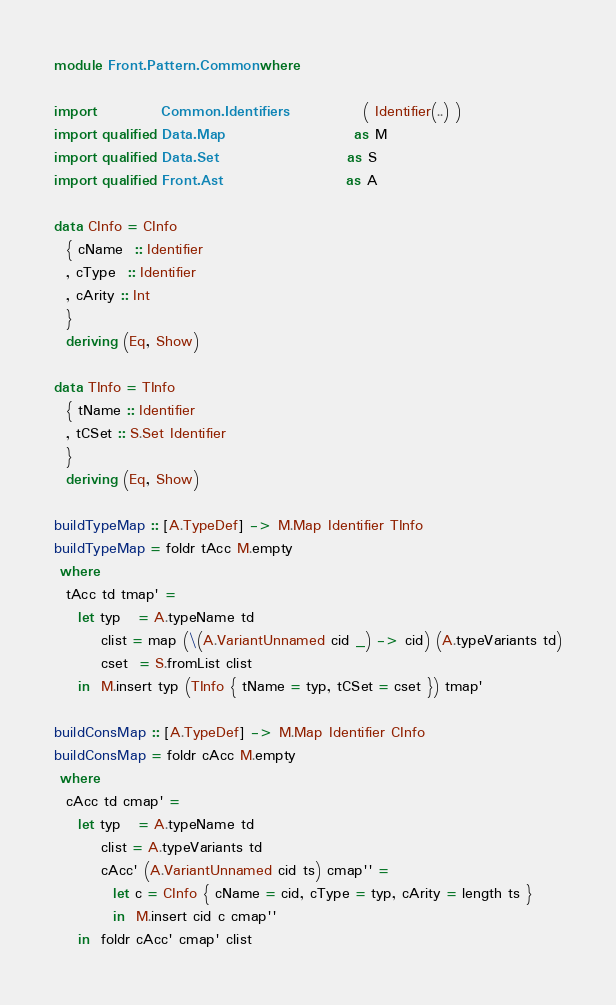<code> <loc_0><loc_0><loc_500><loc_500><_Haskell_>module Front.Pattern.Common where

import           Common.Identifiers             ( Identifier(..) )
import qualified Data.Map                      as M
import qualified Data.Set                      as S
import qualified Front.Ast                     as A

data CInfo = CInfo
  { cName  :: Identifier
  , cType  :: Identifier
  , cArity :: Int
  }
  deriving (Eq, Show)

data TInfo = TInfo
  { tName :: Identifier
  , tCSet :: S.Set Identifier
  }
  deriving (Eq, Show)

buildTypeMap :: [A.TypeDef] -> M.Map Identifier TInfo
buildTypeMap = foldr tAcc M.empty
 where
  tAcc td tmap' =
    let typ   = A.typeName td
        clist = map (\(A.VariantUnnamed cid _) -> cid) (A.typeVariants td)
        cset  = S.fromList clist
    in  M.insert typ (TInfo { tName = typ, tCSet = cset }) tmap'

buildConsMap :: [A.TypeDef] -> M.Map Identifier CInfo
buildConsMap = foldr cAcc M.empty
 where
  cAcc td cmap' =
    let typ   = A.typeName td
        clist = A.typeVariants td
        cAcc' (A.VariantUnnamed cid ts) cmap'' =
          let c = CInfo { cName = cid, cType = typ, cArity = length ts }
          in  M.insert cid c cmap''
    in  foldr cAcc' cmap' clist
</code> 